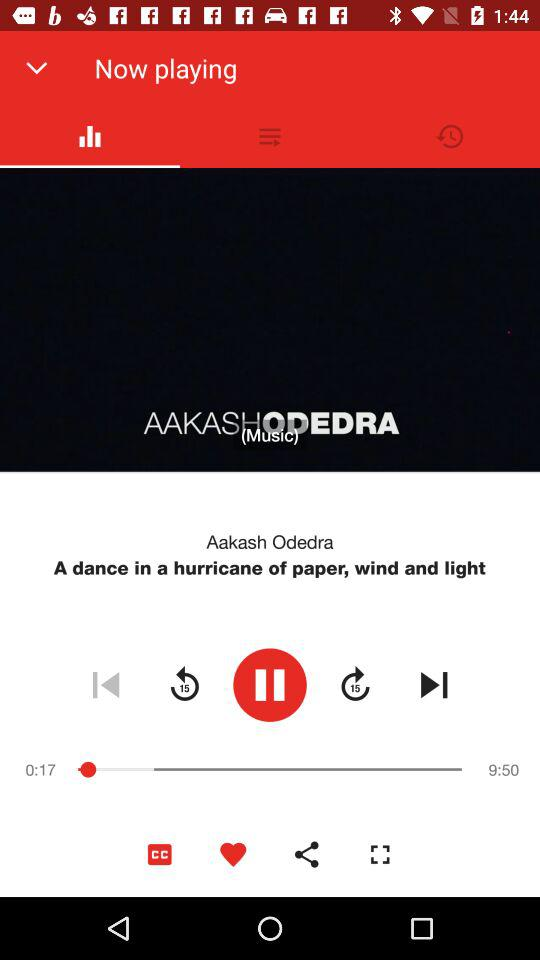Which applications are available for sharing the audio file?
When the provided information is insufficient, respond with <no answer>. <no answer> 